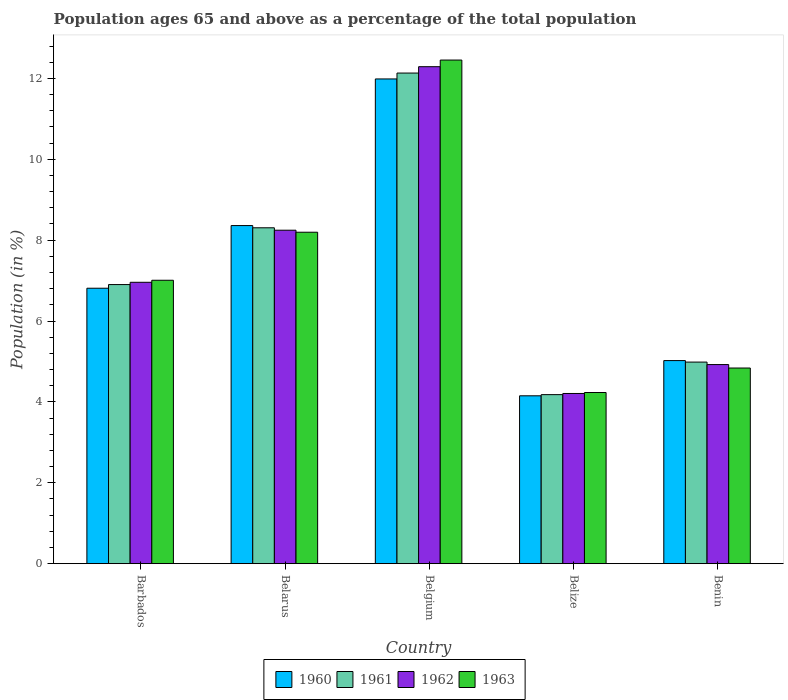How many groups of bars are there?
Your response must be concise. 5. How many bars are there on the 2nd tick from the right?
Your response must be concise. 4. What is the label of the 2nd group of bars from the left?
Your answer should be compact. Belarus. In how many cases, is the number of bars for a given country not equal to the number of legend labels?
Your response must be concise. 0. What is the percentage of the population ages 65 and above in 1960 in Benin?
Offer a very short reply. 5.02. Across all countries, what is the maximum percentage of the population ages 65 and above in 1961?
Keep it short and to the point. 12.13. Across all countries, what is the minimum percentage of the population ages 65 and above in 1960?
Ensure brevity in your answer.  4.15. In which country was the percentage of the population ages 65 and above in 1961 minimum?
Ensure brevity in your answer.  Belize. What is the total percentage of the population ages 65 and above in 1963 in the graph?
Provide a succinct answer. 36.73. What is the difference between the percentage of the population ages 65 and above in 1960 in Barbados and that in Belgium?
Provide a succinct answer. -5.17. What is the difference between the percentage of the population ages 65 and above in 1962 in Belgium and the percentage of the population ages 65 and above in 1961 in Benin?
Keep it short and to the point. 7.3. What is the average percentage of the population ages 65 and above in 1962 per country?
Give a very brief answer. 7.32. What is the difference between the percentage of the population ages 65 and above of/in 1961 and percentage of the population ages 65 and above of/in 1962 in Belize?
Keep it short and to the point. -0.03. In how many countries, is the percentage of the population ages 65 and above in 1963 greater than 1.6?
Give a very brief answer. 5. What is the ratio of the percentage of the population ages 65 and above in 1963 in Belgium to that in Belize?
Offer a terse response. 2.94. What is the difference between the highest and the second highest percentage of the population ages 65 and above in 1962?
Your response must be concise. -4.04. What is the difference between the highest and the lowest percentage of the population ages 65 and above in 1960?
Ensure brevity in your answer.  7.84. Is it the case that in every country, the sum of the percentage of the population ages 65 and above in 1963 and percentage of the population ages 65 and above in 1962 is greater than the sum of percentage of the population ages 65 and above in 1960 and percentage of the population ages 65 and above in 1961?
Provide a succinct answer. No. What does the 4th bar from the right in Barbados represents?
Ensure brevity in your answer.  1960. How many bars are there?
Keep it short and to the point. 20. Are the values on the major ticks of Y-axis written in scientific E-notation?
Your answer should be very brief. No. Does the graph contain grids?
Provide a short and direct response. No. How many legend labels are there?
Your answer should be compact. 4. How are the legend labels stacked?
Your answer should be compact. Horizontal. What is the title of the graph?
Keep it short and to the point. Population ages 65 and above as a percentage of the total population. Does "2008" appear as one of the legend labels in the graph?
Offer a terse response. No. What is the label or title of the X-axis?
Your answer should be compact. Country. What is the label or title of the Y-axis?
Your response must be concise. Population (in %). What is the Population (in %) of 1960 in Barbados?
Ensure brevity in your answer.  6.81. What is the Population (in %) of 1961 in Barbados?
Keep it short and to the point. 6.9. What is the Population (in %) of 1962 in Barbados?
Offer a very short reply. 6.96. What is the Population (in %) in 1963 in Barbados?
Offer a terse response. 7.01. What is the Population (in %) of 1960 in Belarus?
Provide a short and direct response. 8.36. What is the Population (in %) of 1961 in Belarus?
Provide a succinct answer. 8.3. What is the Population (in %) in 1962 in Belarus?
Offer a terse response. 8.25. What is the Population (in %) in 1963 in Belarus?
Provide a short and direct response. 8.2. What is the Population (in %) in 1960 in Belgium?
Your answer should be compact. 11.99. What is the Population (in %) in 1961 in Belgium?
Provide a short and direct response. 12.13. What is the Population (in %) in 1962 in Belgium?
Your response must be concise. 12.29. What is the Population (in %) of 1963 in Belgium?
Provide a succinct answer. 12.45. What is the Population (in %) in 1960 in Belize?
Make the answer very short. 4.15. What is the Population (in %) of 1961 in Belize?
Make the answer very short. 4.18. What is the Population (in %) of 1962 in Belize?
Offer a terse response. 4.21. What is the Population (in %) of 1963 in Belize?
Keep it short and to the point. 4.23. What is the Population (in %) of 1960 in Benin?
Your answer should be compact. 5.02. What is the Population (in %) of 1961 in Benin?
Provide a succinct answer. 4.98. What is the Population (in %) of 1962 in Benin?
Give a very brief answer. 4.92. What is the Population (in %) in 1963 in Benin?
Ensure brevity in your answer.  4.84. Across all countries, what is the maximum Population (in %) in 1960?
Offer a terse response. 11.99. Across all countries, what is the maximum Population (in %) of 1961?
Provide a short and direct response. 12.13. Across all countries, what is the maximum Population (in %) of 1962?
Keep it short and to the point. 12.29. Across all countries, what is the maximum Population (in %) of 1963?
Your answer should be compact. 12.45. Across all countries, what is the minimum Population (in %) in 1960?
Make the answer very short. 4.15. Across all countries, what is the minimum Population (in %) in 1961?
Make the answer very short. 4.18. Across all countries, what is the minimum Population (in %) of 1962?
Give a very brief answer. 4.21. Across all countries, what is the minimum Population (in %) of 1963?
Provide a succinct answer. 4.23. What is the total Population (in %) of 1960 in the graph?
Make the answer very short. 36.33. What is the total Population (in %) in 1961 in the graph?
Offer a terse response. 36.5. What is the total Population (in %) in 1962 in the graph?
Offer a very short reply. 36.62. What is the total Population (in %) in 1963 in the graph?
Offer a very short reply. 36.73. What is the difference between the Population (in %) of 1960 in Barbados and that in Belarus?
Your answer should be compact. -1.55. What is the difference between the Population (in %) in 1961 in Barbados and that in Belarus?
Offer a terse response. -1.4. What is the difference between the Population (in %) in 1962 in Barbados and that in Belarus?
Your response must be concise. -1.29. What is the difference between the Population (in %) in 1963 in Barbados and that in Belarus?
Ensure brevity in your answer.  -1.19. What is the difference between the Population (in %) in 1960 in Barbados and that in Belgium?
Ensure brevity in your answer.  -5.17. What is the difference between the Population (in %) of 1961 in Barbados and that in Belgium?
Your answer should be compact. -5.23. What is the difference between the Population (in %) of 1962 in Barbados and that in Belgium?
Provide a short and direct response. -5.33. What is the difference between the Population (in %) in 1963 in Barbados and that in Belgium?
Ensure brevity in your answer.  -5.45. What is the difference between the Population (in %) in 1960 in Barbados and that in Belize?
Offer a terse response. 2.66. What is the difference between the Population (in %) in 1961 in Barbados and that in Belize?
Make the answer very short. 2.72. What is the difference between the Population (in %) of 1962 in Barbados and that in Belize?
Provide a short and direct response. 2.75. What is the difference between the Population (in %) of 1963 in Barbados and that in Belize?
Provide a succinct answer. 2.78. What is the difference between the Population (in %) of 1960 in Barbados and that in Benin?
Your answer should be compact. 1.79. What is the difference between the Population (in %) in 1961 in Barbados and that in Benin?
Provide a short and direct response. 1.92. What is the difference between the Population (in %) in 1962 in Barbados and that in Benin?
Provide a succinct answer. 2.03. What is the difference between the Population (in %) in 1963 in Barbados and that in Benin?
Give a very brief answer. 2.17. What is the difference between the Population (in %) of 1960 in Belarus and that in Belgium?
Keep it short and to the point. -3.63. What is the difference between the Population (in %) of 1961 in Belarus and that in Belgium?
Give a very brief answer. -3.83. What is the difference between the Population (in %) in 1962 in Belarus and that in Belgium?
Offer a terse response. -4.04. What is the difference between the Population (in %) in 1963 in Belarus and that in Belgium?
Provide a short and direct response. -4.26. What is the difference between the Population (in %) in 1960 in Belarus and that in Belize?
Keep it short and to the point. 4.21. What is the difference between the Population (in %) of 1961 in Belarus and that in Belize?
Your answer should be very brief. 4.13. What is the difference between the Population (in %) in 1962 in Belarus and that in Belize?
Keep it short and to the point. 4.04. What is the difference between the Population (in %) in 1963 in Belarus and that in Belize?
Your answer should be very brief. 3.96. What is the difference between the Population (in %) in 1960 in Belarus and that in Benin?
Ensure brevity in your answer.  3.34. What is the difference between the Population (in %) in 1961 in Belarus and that in Benin?
Ensure brevity in your answer.  3.32. What is the difference between the Population (in %) of 1962 in Belarus and that in Benin?
Your answer should be compact. 3.32. What is the difference between the Population (in %) in 1963 in Belarus and that in Benin?
Keep it short and to the point. 3.36. What is the difference between the Population (in %) of 1960 in Belgium and that in Belize?
Your answer should be very brief. 7.84. What is the difference between the Population (in %) of 1961 in Belgium and that in Belize?
Keep it short and to the point. 7.95. What is the difference between the Population (in %) of 1962 in Belgium and that in Belize?
Give a very brief answer. 8.08. What is the difference between the Population (in %) of 1963 in Belgium and that in Belize?
Your answer should be very brief. 8.22. What is the difference between the Population (in %) in 1960 in Belgium and that in Benin?
Ensure brevity in your answer.  6.96. What is the difference between the Population (in %) of 1961 in Belgium and that in Benin?
Provide a succinct answer. 7.15. What is the difference between the Population (in %) of 1962 in Belgium and that in Benin?
Your answer should be very brief. 7.37. What is the difference between the Population (in %) in 1963 in Belgium and that in Benin?
Make the answer very short. 7.62. What is the difference between the Population (in %) of 1960 in Belize and that in Benin?
Provide a succinct answer. -0.87. What is the difference between the Population (in %) in 1961 in Belize and that in Benin?
Your answer should be very brief. -0.8. What is the difference between the Population (in %) of 1962 in Belize and that in Benin?
Give a very brief answer. -0.71. What is the difference between the Population (in %) in 1963 in Belize and that in Benin?
Make the answer very short. -0.61. What is the difference between the Population (in %) of 1960 in Barbados and the Population (in %) of 1961 in Belarus?
Provide a succinct answer. -1.49. What is the difference between the Population (in %) of 1960 in Barbados and the Population (in %) of 1962 in Belarus?
Keep it short and to the point. -1.43. What is the difference between the Population (in %) of 1960 in Barbados and the Population (in %) of 1963 in Belarus?
Provide a succinct answer. -1.38. What is the difference between the Population (in %) in 1961 in Barbados and the Population (in %) in 1962 in Belarus?
Ensure brevity in your answer.  -1.34. What is the difference between the Population (in %) of 1961 in Barbados and the Population (in %) of 1963 in Belarus?
Your answer should be very brief. -1.29. What is the difference between the Population (in %) in 1962 in Barbados and the Population (in %) in 1963 in Belarus?
Your response must be concise. -1.24. What is the difference between the Population (in %) of 1960 in Barbados and the Population (in %) of 1961 in Belgium?
Make the answer very short. -5.32. What is the difference between the Population (in %) in 1960 in Barbados and the Population (in %) in 1962 in Belgium?
Your response must be concise. -5.48. What is the difference between the Population (in %) of 1960 in Barbados and the Population (in %) of 1963 in Belgium?
Your answer should be very brief. -5.64. What is the difference between the Population (in %) in 1961 in Barbados and the Population (in %) in 1962 in Belgium?
Offer a very short reply. -5.39. What is the difference between the Population (in %) in 1961 in Barbados and the Population (in %) in 1963 in Belgium?
Give a very brief answer. -5.55. What is the difference between the Population (in %) in 1962 in Barbados and the Population (in %) in 1963 in Belgium?
Your answer should be very brief. -5.5. What is the difference between the Population (in %) of 1960 in Barbados and the Population (in %) of 1961 in Belize?
Your answer should be very brief. 2.63. What is the difference between the Population (in %) in 1960 in Barbados and the Population (in %) in 1962 in Belize?
Provide a short and direct response. 2.6. What is the difference between the Population (in %) of 1960 in Barbados and the Population (in %) of 1963 in Belize?
Keep it short and to the point. 2.58. What is the difference between the Population (in %) in 1961 in Barbados and the Population (in %) in 1962 in Belize?
Offer a terse response. 2.69. What is the difference between the Population (in %) of 1961 in Barbados and the Population (in %) of 1963 in Belize?
Provide a succinct answer. 2.67. What is the difference between the Population (in %) in 1962 in Barbados and the Population (in %) in 1963 in Belize?
Make the answer very short. 2.73. What is the difference between the Population (in %) in 1960 in Barbados and the Population (in %) in 1961 in Benin?
Your answer should be very brief. 1.83. What is the difference between the Population (in %) in 1960 in Barbados and the Population (in %) in 1962 in Benin?
Make the answer very short. 1.89. What is the difference between the Population (in %) of 1960 in Barbados and the Population (in %) of 1963 in Benin?
Your response must be concise. 1.97. What is the difference between the Population (in %) of 1961 in Barbados and the Population (in %) of 1962 in Benin?
Ensure brevity in your answer.  1.98. What is the difference between the Population (in %) of 1961 in Barbados and the Population (in %) of 1963 in Benin?
Ensure brevity in your answer.  2.06. What is the difference between the Population (in %) of 1962 in Barbados and the Population (in %) of 1963 in Benin?
Your answer should be very brief. 2.12. What is the difference between the Population (in %) in 1960 in Belarus and the Population (in %) in 1961 in Belgium?
Your answer should be very brief. -3.77. What is the difference between the Population (in %) in 1960 in Belarus and the Population (in %) in 1962 in Belgium?
Give a very brief answer. -3.93. What is the difference between the Population (in %) of 1960 in Belarus and the Population (in %) of 1963 in Belgium?
Provide a succinct answer. -4.09. What is the difference between the Population (in %) in 1961 in Belarus and the Population (in %) in 1962 in Belgium?
Ensure brevity in your answer.  -3.98. What is the difference between the Population (in %) of 1961 in Belarus and the Population (in %) of 1963 in Belgium?
Your answer should be very brief. -4.15. What is the difference between the Population (in %) in 1962 in Belarus and the Population (in %) in 1963 in Belgium?
Provide a short and direct response. -4.21. What is the difference between the Population (in %) in 1960 in Belarus and the Population (in %) in 1961 in Belize?
Provide a short and direct response. 4.18. What is the difference between the Population (in %) in 1960 in Belarus and the Population (in %) in 1962 in Belize?
Your answer should be very brief. 4.15. What is the difference between the Population (in %) of 1960 in Belarus and the Population (in %) of 1963 in Belize?
Provide a short and direct response. 4.13. What is the difference between the Population (in %) in 1961 in Belarus and the Population (in %) in 1962 in Belize?
Offer a very short reply. 4.1. What is the difference between the Population (in %) in 1961 in Belarus and the Population (in %) in 1963 in Belize?
Provide a short and direct response. 4.07. What is the difference between the Population (in %) of 1962 in Belarus and the Population (in %) of 1963 in Belize?
Provide a succinct answer. 4.01. What is the difference between the Population (in %) in 1960 in Belarus and the Population (in %) in 1961 in Benin?
Your answer should be compact. 3.38. What is the difference between the Population (in %) of 1960 in Belarus and the Population (in %) of 1962 in Benin?
Offer a very short reply. 3.44. What is the difference between the Population (in %) of 1960 in Belarus and the Population (in %) of 1963 in Benin?
Give a very brief answer. 3.52. What is the difference between the Population (in %) of 1961 in Belarus and the Population (in %) of 1962 in Benin?
Offer a very short reply. 3.38. What is the difference between the Population (in %) in 1961 in Belarus and the Population (in %) in 1963 in Benin?
Give a very brief answer. 3.47. What is the difference between the Population (in %) in 1962 in Belarus and the Population (in %) in 1963 in Benin?
Give a very brief answer. 3.41. What is the difference between the Population (in %) in 1960 in Belgium and the Population (in %) in 1961 in Belize?
Give a very brief answer. 7.81. What is the difference between the Population (in %) in 1960 in Belgium and the Population (in %) in 1962 in Belize?
Offer a very short reply. 7.78. What is the difference between the Population (in %) of 1960 in Belgium and the Population (in %) of 1963 in Belize?
Provide a short and direct response. 7.75. What is the difference between the Population (in %) of 1961 in Belgium and the Population (in %) of 1962 in Belize?
Your answer should be compact. 7.92. What is the difference between the Population (in %) of 1961 in Belgium and the Population (in %) of 1963 in Belize?
Your response must be concise. 7.9. What is the difference between the Population (in %) in 1962 in Belgium and the Population (in %) in 1963 in Belize?
Provide a succinct answer. 8.06. What is the difference between the Population (in %) in 1960 in Belgium and the Population (in %) in 1961 in Benin?
Give a very brief answer. 7. What is the difference between the Population (in %) of 1960 in Belgium and the Population (in %) of 1962 in Benin?
Give a very brief answer. 7.06. What is the difference between the Population (in %) in 1960 in Belgium and the Population (in %) in 1963 in Benin?
Give a very brief answer. 7.15. What is the difference between the Population (in %) in 1961 in Belgium and the Population (in %) in 1962 in Benin?
Your answer should be compact. 7.21. What is the difference between the Population (in %) of 1961 in Belgium and the Population (in %) of 1963 in Benin?
Keep it short and to the point. 7.29. What is the difference between the Population (in %) of 1962 in Belgium and the Population (in %) of 1963 in Benin?
Keep it short and to the point. 7.45. What is the difference between the Population (in %) of 1960 in Belize and the Population (in %) of 1961 in Benin?
Keep it short and to the point. -0.83. What is the difference between the Population (in %) in 1960 in Belize and the Population (in %) in 1962 in Benin?
Ensure brevity in your answer.  -0.77. What is the difference between the Population (in %) in 1960 in Belize and the Population (in %) in 1963 in Benin?
Ensure brevity in your answer.  -0.69. What is the difference between the Population (in %) of 1961 in Belize and the Population (in %) of 1962 in Benin?
Offer a terse response. -0.74. What is the difference between the Population (in %) in 1961 in Belize and the Population (in %) in 1963 in Benin?
Offer a terse response. -0.66. What is the difference between the Population (in %) of 1962 in Belize and the Population (in %) of 1963 in Benin?
Make the answer very short. -0.63. What is the average Population (in %) in 1960 per country?
Your answer should be compact. 7.27. What is the average Population (in %) of 1961 per country?
Ensure brevity in your answer.  7.3. What is the average Population (in %) of 1962 per country?
Ensure brevity in your answer.  7.32. What is the average Population (in %) in 1963 per country?
Give a very brief answer. 7.35. What is the difference between the Population (in %) of 1960 and Population (in %) of 1961 in Barbados?
Ensure brevity in your answer.  -0.09. What is the difference between the Population (in %) in 1960 and Population (in %) in 1962 in Barbados?
Make the answer very short. -0.15. What is the difference between the Population (in %) of 1960 and Population (in %) of 1963 in Barbados?
Your answer should be compact. -0.2. What is the difference between the Population (in %) of 1961 and Population (in %) of 1962 in Barbados?
Offer a terse response. -0.06. What is the difference between the Population (in %) in 1961 and Population (in %) in 1963 in Barbados?
Offer a very short reply. -0.11. What is the difference between the Population (in %) in 1962 and Population (in %) in 1963 in Barbados?
Provide a succinct answer. -0.05. What is the difference between the Population (in %) in 1960 and Population (in %) in 1961 in Belarus?
Make the answer very short. 0.05. What is the difference between the Population (in %) in 1960 and Population (in %) in 1962 in Belarus?
Make the answer very short. 0.11. What is the difference between the Population (in %) in 1960 and Population (in %) in 1963 in Belarus?
Your answer should be compact. 0.16. What is the difference between the Population (in %) of 1961 and Population (in %) of 1962 in Belarus?
Ensure brevity in your answer.  0.06. What is the difference between the Population (in %) in 1961 and Population (in %) in 1963 in Belarus?
Ensure brevity in your answer.  0.11. What is the difference between the Population (in %) of 1962 and Population (in %) of 1963 in Belarus?
Provide a succinct answer. 0.05. What is the difference between the Population (in %) in 1960 and Population (in %) in 1961 in Belgium?
Your response must be concise. -0.15. What is the difference between the Population (in %) in 1960 and Population (in %) in 1962 in Belgium?
Offer a very short reply. -0.3. What is the difference between the Population (in %) of 1960 and Population (in %) of 1963 in Belgium?
Offer a very short reply. -0.47. What is the difference between the Population (in %) of 1961 and Population (in %) of 1962 in Belgium?
Keep it short and to the point. -0.16. What is the difference between the Population (in %) in 1961 and Population (in %) in 1963 in Belgium?
Offer a very short reply. -0.32. What is the difference between the Population (in %) of 1962 and Population (in %) of 1963 in Belgium?
Provide a short and direct response. -0.16. What is the difference between the Population (in %) in 1960 and Population (in %) in 1961 in Belize?
Give a very brief answer. -0.03. What is the difference between the Population (in %) in 1960 and Population (in %) in 1962 in Belize?
Offer a very short reply. -0.06. What is the difference between the Population (in %) in 1960 and Population (in %) in 1963 in Belize?
Provide a succinct answer. -0.08. What is the difference between the Population (in %) in 1961 and Population (in %) in 1962 in Belize?
Keep it short and to the point. -0.03. What is the difference between the Population (in %) of 1961 and Population (in %) of 1963 in Belize?
Your response must be concise. -0.05. What is the difference between the Population (in %) of 1962 and Population (in %) of 1963 in Belize?
Your answer should be compact. -0.02. What is the difference between the Population (in %) in 1960 and Population (in %) in 1961 in Benin?
Your answer should be compact. 0.04. What is the difference between the Population (in %) in 1960 and Population (in %) in 1962 in Benin?
Offer a very short reply. 0.1. What is the difference between the Population (in %) of 1960 and Population (in %) of 1963 in Benin?
Your answer should be very brief. 0.18. What is the difference between the Population (in %) in 1961 and Population (in %) in 1962 in Benin?
Make the answer very short. 0.06. What is the difference between the Population (in %) in 1961 and Population (in %) in 1963 in Benin?
Your answer should be very brief. 0.15. What is the difference between the Population (in %) in 1962 and Population (in %) in 1963 in Benin?
Keep it short and to the point. 0.09. What is the ratio of the Population (in %) in 1960 in Barbados to that in Belarus?
Give a very brief answer. 0.81. What is the ratio of the Population (in %) in 1961 in Barbados to that in Belarus?
Your answer should be compact. 0.83. What is the ratio of the Population (in %) of 1962 in Barbados to that in Belarus?
Offer a terse response. 0.84. What is the ratio of the Population (in %) of 1963 in Barbados to that in Belarus?
Keep it short and to the point. 0.86. What is the ratio of the Population (in %) of 1960 in Barbados to that in Belgium?
Provide a succinct answer. 0.57. What is the ratio of the Population (in %) of 1961 in Barbados to that in Belgium?
Make the answer very short. 0.57. What is the ratio of the Population (in %) in 1962 in Barbados to that in Belgium?
Provide a short and direct response. 0.57. What is the ratio of the Population (in %) in 1963 in Barbados to that in Belgium?
Your response must be concise. 0.56. What is the ratio of the Population (in %) of 1960 in Barbados to that in Belize?
Give a very brief answer. 1.64. What is the ratio of the Population (in %) of 1961 in Barbados to that in Belize?
Ensure brevity in your answer.  1.65. What is the ratio of the Population (in %) of 1962 in Barbados to that in Belize?
Give a very brief answer. 1.65. What is the ratio of the Population (in %) in 1963 in Barbados to that in Belize?
Make the answer very short. 1.66. What is the ratio of the Population (in %) in 1960 in Barbados to that in Benin?
Keep it short and to the point. 1.36. What is the ratio of the Population (in %) in 1961 in Barbados to that in Benin?
Your answer should be compact. 1.38. What is the ratio of the Population (in %) in 1962 in Barbados to that in Benin?
Your answer should be very brief. 1.41. What is the ratio of the Population (in %) of 1963 in Barbados to that in Benin?
Your response must be concise. 1.45. What is the ratio of the Population (in %) of 1960 in Belarus to that in Belgium?
Give a very brief answer. 0.7. What is the ratio of the Population (in %) of 1961 in Belarus to that in Belgium?
Make the answer very short. 0.68. What is the ratio of the Population (in %) of 1962 in Belarus to that in Belgium?
Provide a short and direct response. 0.67. What is the ratio of the Population (in %) of 1963 in Belarus to that in Belgium?
Your answer should be compact. 0.66. What is the ratio of the Population (in %) in 1960 in Belarus to that in Belize?
Your answer should be very brief. 2.01. What is the ratio of the Population (in %) in 1961 in Belarus to that in Belize?
Keep it short and to the point. 1.99. What is the ratio of the Population (in %) in 1962 in Belarus to that in Belize?
Offer a terse response. 1.96. What is the ratio of the Population (in %) in 1963 in Belarus to that in Belize?
Offer a terse response. 1.94. What is the ratio of the Population (in %) in 1960 in Belarus to that in Benin?
Your answer should be compact. 1.66. What is the ratio of the Population (in %) in 1961 in Belarus to that in Benin?
Make the answer very short. 1.67. What is the ratio of the Population (in %) of 1962 in Belarus to that in Benin?
Your answer should be very brief. 1.67. What is the ratio of the Population (in %) of 1963 in Belarus to that in Benin?
Make the answer very short. 1.69. What is the ratio of the Population (in %) in 1960 in Belgium to that in Belize?
Give a very brief answer. 2.89. What is the ratio of the Population (in %) in 1961 in Belgium to that in Belize?
Provide a short and direct response. 2.9. What is the ratio of the Population (in %) of 1962 in Belgium to that in Belize?
Provide a succinct answer. 2.92. What is the ratio of the Population (in %) of 1963 in Belgium to that in Belize?
Your answer should be compact. 2.94. What is the ratio of the Population (in %) in 1960 in Belgium to that in Benin?
Your answer should be compact. 2.39. What is the ratio of the Population (in %) in 1961 in Belgium to that in Benin?
Provide a short and direct response. 2.43. What is the ratio of the Population (in %) in 1962 in Belgium to that in Benin?
Provide a succinct answer. 2.5. What is the ratio of the Population (in %) in 1963 in Belgium to that in Benin?
Keep it short and to the point. 2.57. What is the ratio of the Population (in %) of 1960 in Belize to that in Benin?
Ensure brevity in your answer.  0.83. What is the ratio of the Population (in %) in 1961 in Belize to that in Benin?
Provide a short and direct response. 0.84. What is the ratio of the Population (in %) in 1962 in Belize to that in Benin?
Offer a terse response. 0.85. What is the ratio of the Population (in %) in 1963 in Belize to that in Benin?
Offer a terse response. 0.87. What is the difference between the highest and the second highest Population (in %) of 1960?
Make the answer very short. 3.63. What is the difference between the highest and the second highest Population (in %) in 1961?
Provide a succinct answer. 3.83. What is the difference between the highest and the second highest Population (in %) of 1962?
Offer a very short reply. 4.04. What is the difference between the highest and the second highest Population (in %) of 1963?
Keep it short and to the point. 4.26. What is the difference between the highest and the lowest Population (in %) in 1960?
Ensure brevity in your answer.  7.84. What is the difference between the highest and the lowest Population (in %) in 1961?
Make the answer very short. 7.95. What is the difference between the highest and the lowest Population (in %) of 1962?
Your response must be concise. 8.08. What is the difference between the highest and the lowest Population (in %) of 1963?
Make the answer very short. 8.22. 